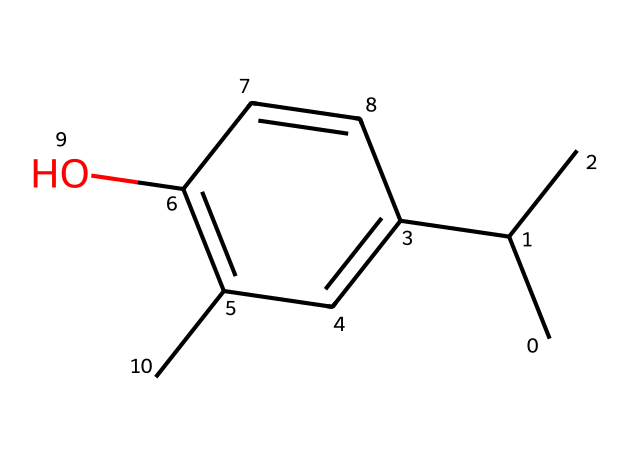What is the name of this chemical? The structure corresponds to thymol, which is indicated by its specific arrangement of atoms and functional groups, including the presence of the hydroxyl (OH) group and the cyclic structure.
Answer: thymol How many carbon atoms are present in the structure? By examining the SMILES representation and counting the carbon symbols (C), we identify there are fifteen carbon atoms in the structure.
Answer: fifteen What type of compound is thymol classified as? Thymol is classified as a phenolic compound due to the presence of the aromatic ring and the hydroxyl group (OH) attached to it, characteristic of phenols.
Answer: phenol How many hydroxyl groups are present in the structure? Looking at the structure, there is one hydroxyl (OH) group attached to the aromatic ring of the thymol molecule, clearly indicating the presence of a single hydroxyl group.
Answer: one What is the significance of the hydroxyl group in thymol? The hydroxyl group contributes to the solubility and antibacterial properties of thymol, making it effective in medicinal applications, thus emphasizing its functionality in pharmacology.
Answer: antibacterial properties Which functional groups are present in thymol? In the structure, the primary functional groups are the hydroxyl group and the aromatic ring, which are essential for its reactivity and biological activity.
Answer: hydroxyl and aromatic 